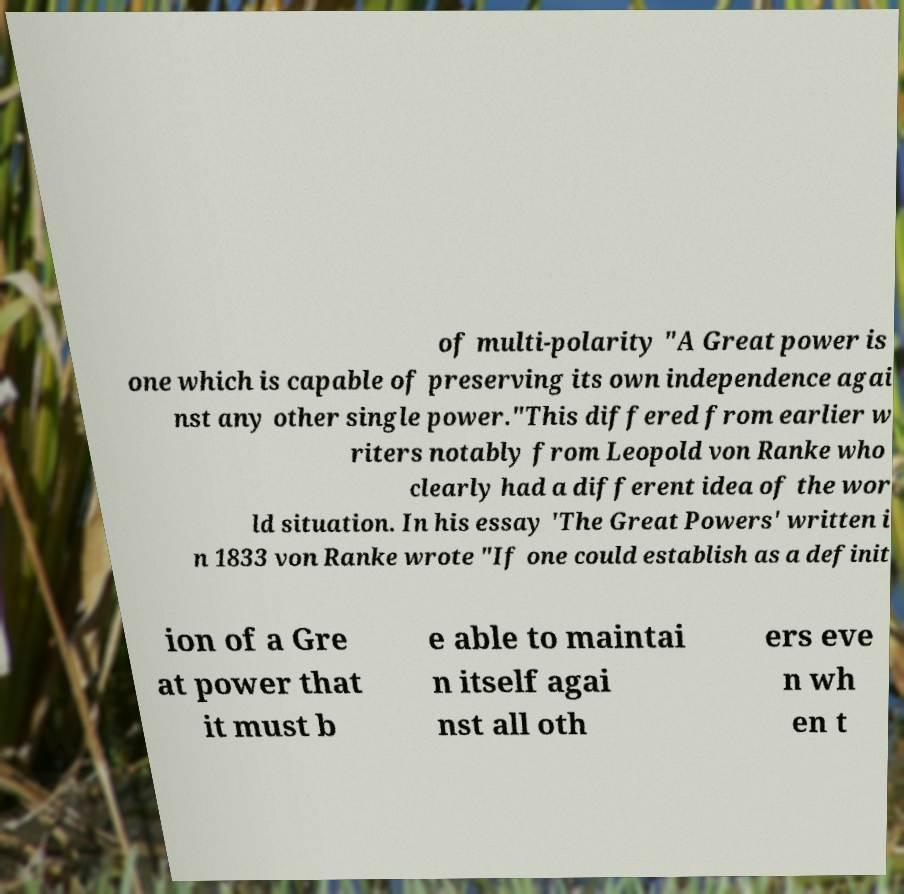Can you accurately transcribe the text from the provided image for me? of multi-polarity "A Great power is one which is capable of preserving its own independence agai nst any other single power."This differed from earlier w riters notably from Leopold von Ranke who clearly had a different idea of the wor ld situation. In his essay 'The Great Powers' written i n 1833 von Ranke wrote "If one could establish as a definit ion of a Gre at power that it must b e able to maintai n itself agai nst all oth ers eve n wh en t 